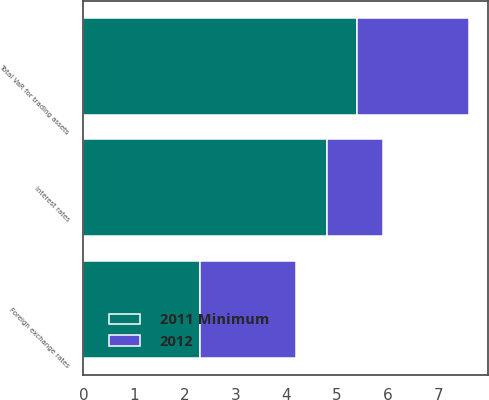Convert chart to OTSL. <chart><loc_0><loc_0><loc_500><loc_500><stacked_bar_chart><ecel><fcel>Foreign exchange rates<fcel>Interest rates<fcel>Total VaR for trading assets<nl><fcel>2012<fcel>1.9<fcel>1.1<fcel>2.2<nl><fcel>2011 Minimum<fcel>2.3<fcel>4.8<fcel>5.4<nl></chart> 